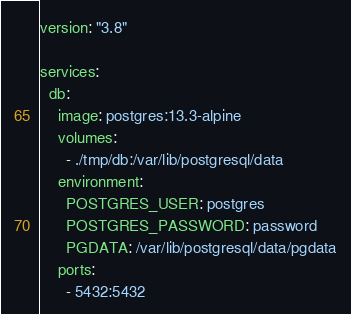<code> <loc_0><loc_0><loc_500><loc_500><_YAML_>version: "3.8"

services:
  db:
    image: postgres:13.3-alpine
    volumes:
      - ./tmp/db:/var/lib/postgresql/data
    environment:
      POSTGRES_USER: postgres
      POSTGRES_PASSWORD: password
      PGDATA: /var/lib/postgresql/data/pgdata
    ports:
      - 5432:5432
</code> 